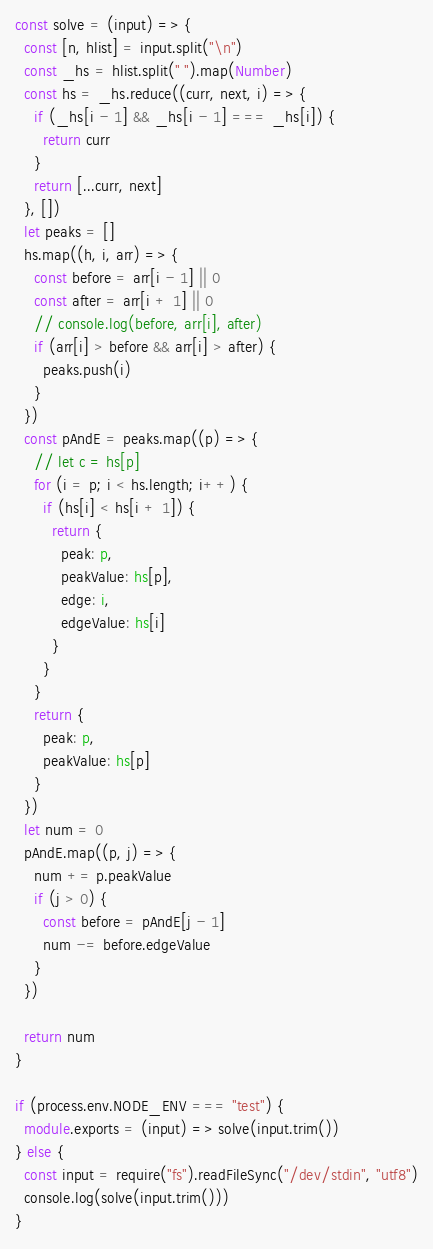Convert code to text. <code><loc_0><loc_0><loc_500><loc_500><_TypeScript_>const solve = (input) => {
  const [n, hlist] = input.split("\n")
  const _hs = hlist.split(" ").map(Number)
  const hs = _hs.reduce((curr, next, i) => {
    if (_hs[i - 1] && _hs[i - 1] === _hs[i]) {
      return curr
    }
    return [...curr, next]
  }, [])
  let peaks = []
  hs.map((h, i, arr) => {
    const before = arr[i - 1] || 0
    const after = arr[i + 1] || 0
    // console.log(before, arr[i], after)
    if (arr[i] > before && arr[i] > after) {
      peaks.push(i)
    }
  })
  const pAndE = peaks.map((p) => {
    // let c = hs[p]
    for (i = p; i < hs.length; i++) {
      if (hs[i] < hs[i + 1]) {
        return {
          peak: p,
          peakValue: hs[p],
          edge: i,
          edgeValue: hs[i]
        }
      }
    }
    return {
      peak: p,
      peakValue: hs[p]
    }
  })
  let num = 0
  pAndE.map((p, j) => {
    num += p.peakValue
    if (j > 0) {
      const before = pAndE[j - 1]
      num -= before.edgeValue
    }
  })

  return num
}

if (process.env.NODE_ENV === "test") {
  module.exports = (input) => solve(input.trim())
} else {
  const input = require("fs").readFileSync("/dev/stdin", "utf8")
  console.log(solve(input.trim()))
}
</code> 